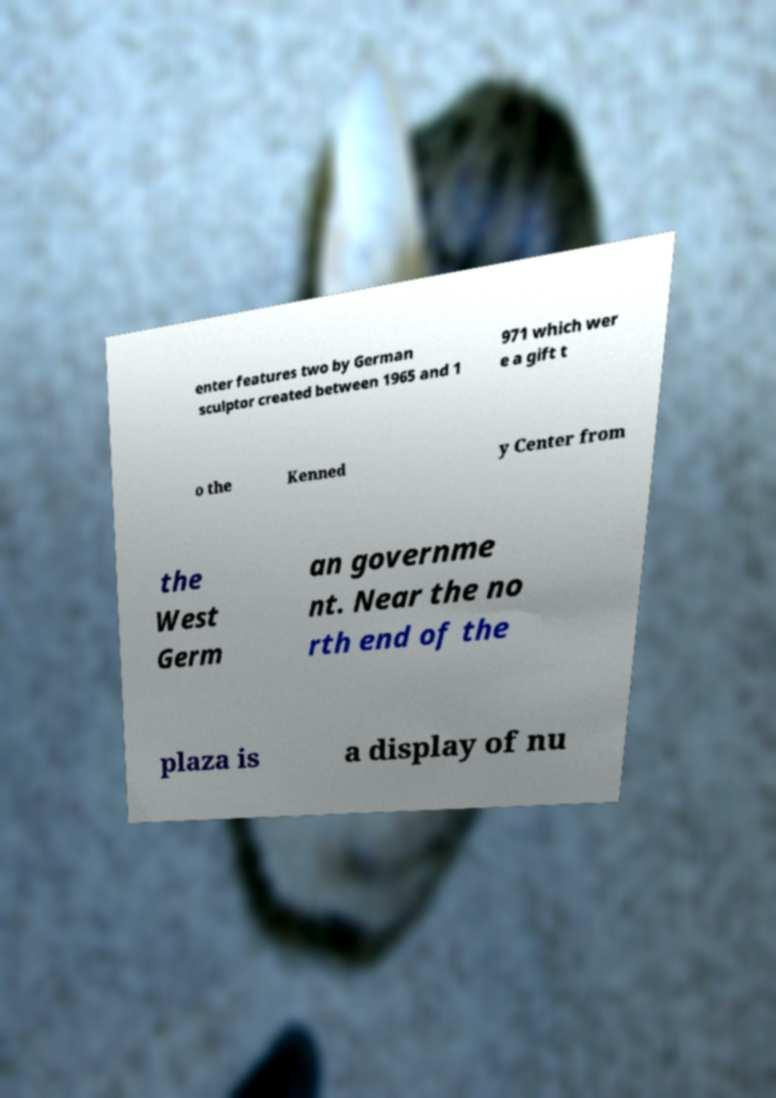Can you read and provide the text displayed in the image?This photo seems to have some interesting text. Can you extract and type it out for me? enter features two by German sculptor created between 1965 and 1 971 which wer e a gift t o the Kenned y Center from the West Germ an governme nt. Near the no rth end of the plaza is a display of nu 